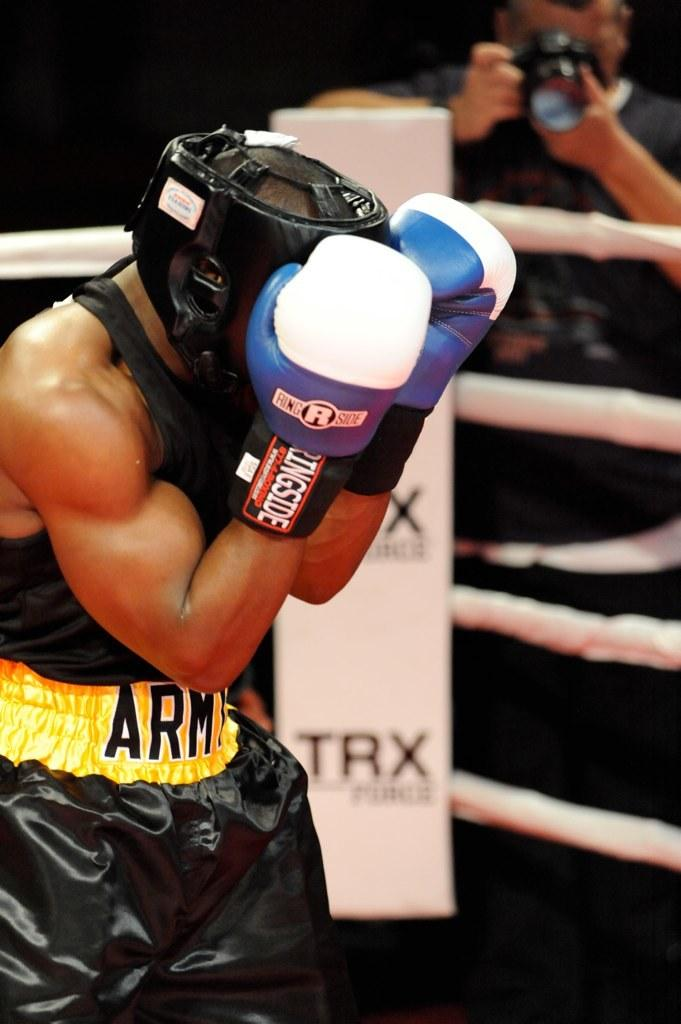What is the person in the image wearing on their head? The person is wearing a helmet in the image. What else is the person wearing on their hands? The person is wearing gloves in the image. Who else is present in the image? There is another person with a camera in the image. What is the color of the background in the image? The background of the image is black. How many ducks are visible in the image? There are no ducks present in the image. What type of sack is being used to mark the person's territory in the image? There is no sack or territory mentioned or depicted in the image. 